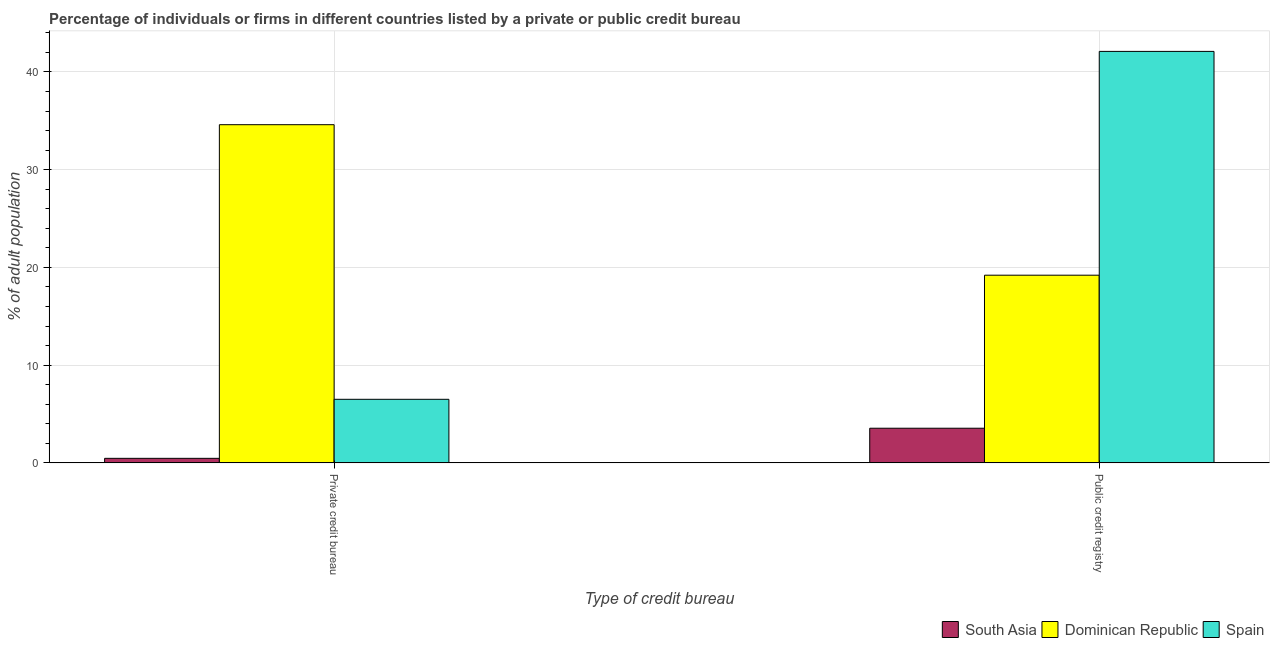How many different coloured bars are there?
Give a very brief answer. 3. How many groups of bars are there?
Ensure brevity in your answer.  2. What is the label of the 2nd group of bars from the left?
Offer a terse response. Public credit registry. What is the percentage of firms listed by private credit bureau in South Asia?
Give a very brief answer. 0.46. Across all countries, what is the maximum percentage of firms listed by private credit bureau?
Your answer should be very brief. 34.6. Across all countries, what is the minimum percentage of firms listed by private credit bureau?
Your answer should be very brief. 0.46. In which country was the percentage of firms listed by private credit bureau maximum?
Ensure brevity in your answer.  Dominican Republic. In which country was the percentage of firms listed by public credit bureau minimum?
Your response must be concise. South Asia. What is the total percentage of firms listed by public credit bureau in the graph?
Your response must be concise. 64.84. What is the difference between the percentage of firms listed by private credit bureau in South Asia and that in Dominican Republic?
Provide a succinct answer. -34.14. What is the difference between the percentage of firms listed by public credit bureau in South Asia and the percentage of firms listed by private credit bureau in Spain?
Keep it short and to the point. -2.96. What is the average percentage of firms listed by private credit bureau per country?
Keep it short and to the point. 13.85. What is the difference between the percentage of firms listed by private credit bureau and percentage of firms listed by public credit bureau in South Asia?
Make the answer very short. -3.08. In how many countries, is the percentage of firms listed by public credit bureau greater than 28 %?
Provide a short and direct response. 1. What is the ratio of the percentage of firms listed by public credit bureau in South Asia to that in Spain?
Keep it short and to the point. 0.08. In how many countries, is the percentage of firms listed by public credit bureau greater than the average percentage of firms listed by public credit bureau taken over all countries?
Keep it short and to the point. 1. How many bars are there?
Your response must be concise. 6. How many countries are there in the graph?
Ensure brevity in your answer.  3. Are the values on the major ticks of Y-axis written in scientific E-notation?
Your answer should be very brief. No. Does the graph contain any zero values?
Ensure brevity in your answer.  No. Where does the legend appear in the graph?
Keep it short and to the point. Bottom right. What is the title of the graph?
Make the answer very short. Percentage of individuals or firms in different countries listed by a private or public credit bureau. What is the label or title of the X-axis?
Your answer should be very brief. Type of credit bureau. What is the label or title of the Y-axis?
Your answer should be very brief. % of adult population. What is the % of adult population of South Asia in Private credit bureau?
Your answer should be very brief. 0.46. What is the % of adult population of Dominican Republic in Private credit bureau?
Your answer should be compact. 34.6. What is the % of adult population of Spain in Private credit bureau?
Your answer should be compact. 6.5. What is the % of adult population of South Asia in Public credit registry?
Give a very brief answer. 3.54. What is the % of adult population in Dominican Republic in Public credit registry?
Offer a very short reply. 19.2. What is the % of adult population in Spain in Public credit registry?
Provide a succinct answer. 42.1. Across all Type of credit bureau, what is the maximum % of adult population in South Asia?
Give a very brief answer. 3.54. Across all Type of credit bureau, what is the maximum % of adult population of Dominican Republic?
Your response must be concise. 34.6. Across all Type of credit bureau, what is the maximum % of adult population of Spain?
Provide a short and direct response. 42.1. Across all Type of credit bureau, what is the minimum % of adult population in South Asia?
Keep it short and to the point. 0.46. Across all Type of credit bureau, what is the minimum % of adult population of Spain?
Provide a succinct answer. 6.5. What is the total % of adult population in South Asia in the graph?
Offer a very short reply. 4. What is the total % of adult population of Dominican Republic in the graph?
Your response must be concise. 53.8. What is the total % of adult population of Spain in the graph?
Your answer should be compact. 48.6. What is the difference between the % of adult population in South Asia in Private credit bureau and that in Public credit registry?
Make the answer very short. -3.08. What is the difference between the % of adult population of Dominican Republic in Private credit bureau and that in Public credit registry?
Make the answer very short. 15.4. What is the difference between the % of adult population in Spain in Private credit bureau and that in Public credit registry?
Provide a succinct answer. -35.6. What is the difference between the % of adult population in South Asia in Private credit bureau and the % of adult population in Dominican Republic in Public credit registry?
Keep it short and to the point. -18.74. What is the difference between the % of adult population of South Asia in Private credit bureau and the % of adult population of Spain in Public credit registry?
Provide a succinct answer. -41.64. What is the difference between the % of adult population of Dominican Republic in Private credit bureau and the % of adult population of Spain in Public credit registry?
Keep it short and to the point. -7.5. What is the average % of adult population in South Asia per Type of credit bureau?
Your response must be concise. 2. What is the average % of adult population in Dominican Republic per Type of credit bureau?
Ensure brevity in your answer.  26.9. What is the average % of adult population in Spain per Type of credit bureau?
Your answer should be compact. 24.3. What is the difference between the % of adult population in South Asia and % of adult population in Dominican Republic in Private credit bureau?
Keep it short and to the point. -34.14. What is the difference between the % of adult population in South Asia and % of adult population in Spain in Private credit bureau?
Make the answer very short. -6.04. What is the difference between the % of adult population in Dominican Republic and % of adult population in Spain in Private credit bureau?
Keep it short and to the point. 28.1. What is the difference between the % of adult population of South Asia and % of adult population of Dominican Republic in Public credit registry?
Your answer should be compact. -15.66. What is the difference between the % of adult population in South Asia and % of adult population in Spain in Public credit registry?
Keep it short and to the point. -38.56. What is the difference between the % of adult population in Dominican Republic and % of adult population in Spain in Public credit registry?
Make the answer very short. -22.9. What is the ratio of the % of adult population of South Asia in Private credit bureau to that in Public credit registry?
Ensure brevity in your answer.  0.13. What is the ratio of the % of adult population of Dominican Republic in Private credit bureau to that in Public credit registry?
Your answer should be very brief. 1.8. What is the ratio of the % of adult population of Spain in Private credit bureau to that in Public credit registry?
Offer a terse response. 0.15. What is the difference between the highest and the second highest % of adult population in South Asia?
Provide a succinct answer. 3.08. What is the difference between the highest and the second highest % of adult population of Spain?
Your answer should be compact. 35.6. What is the difference between the highest and the lowest % of adult population of South Asia?
Your answer should be compact. 3.08. What is the difference between the highest and the lowest % of adult population in Dominican Republic?
Provide a short and direct response. 15.4. What is the difference between the highest and the lowest % of adult population of Spain?
Make the answer very short. 35.6. 